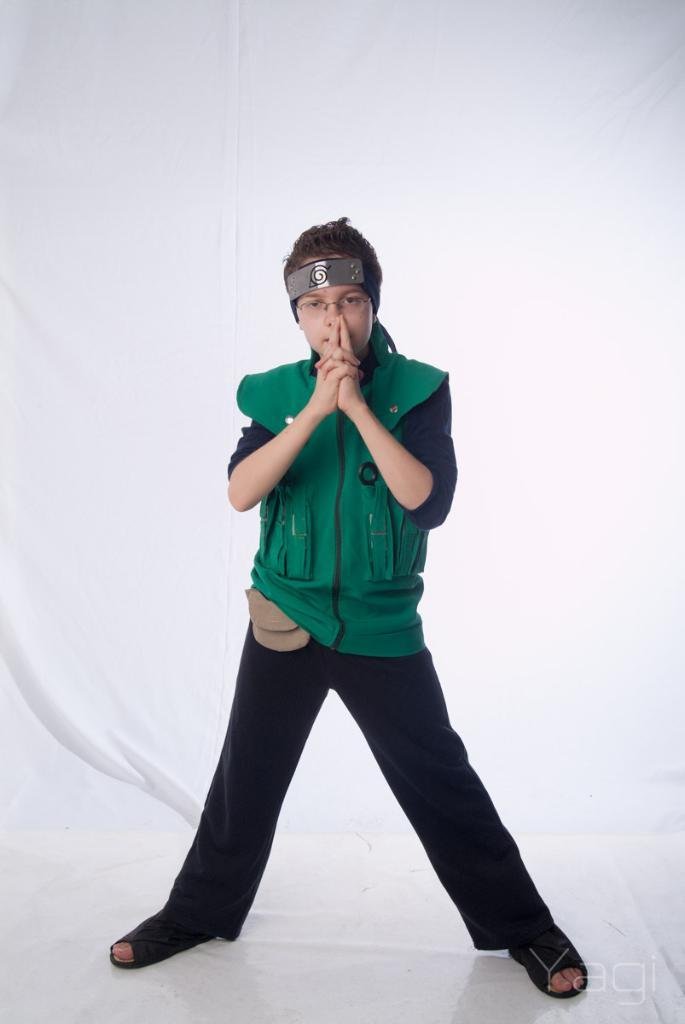Who is the main subject in the image? There is a child in the image. What is the child doing in the image? The child is standing on the floor. What is the child wearing in the image? The child is wearing a jacket. What else can be seen in the background of the image? There is a curtain visible in the image. How many kittens are playing with the stem of a heart in the image? There are no kittens or hearts present in the image. 